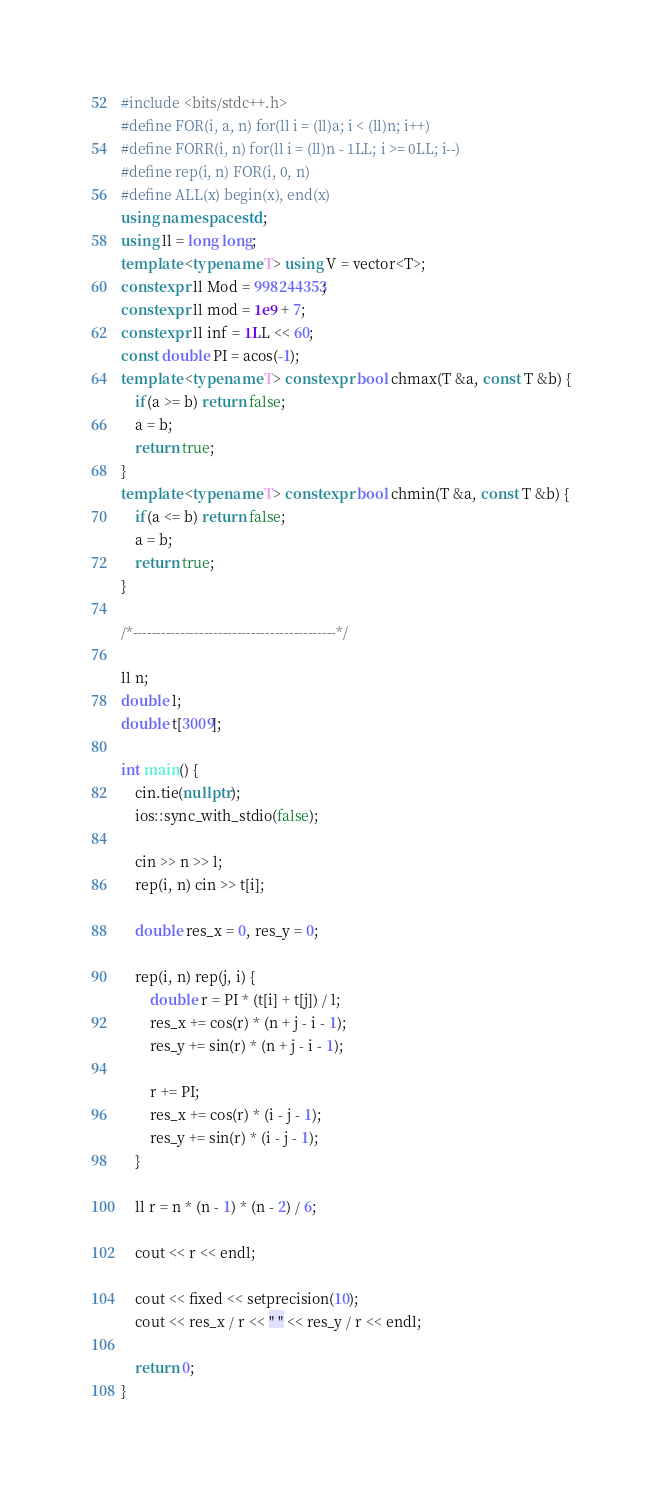Convert code to text. <code><loc_0><loc_0><loc_500><loc_500><_C++_>#include <bits/stdc++.h>
#define FOR(i, a, n) for(ll i = (ll)a; i < (ll)n; i++)
#define FORR(i, n) for(ll i = (ll)n - 1LL; i >= 0LL; i--)
#define rep(i, n) FOR(i, 0, n)
#define ALL(x) begin(x), end(x)
using namespace std;
using ll = long long;
template <typename T> using V = vector<T>;
constexpr ll Mod = 998244353;
constexpr ll mod = 1e9 + 7;
constexpr ll inf = 1LL << 60;
const double PI = acos(-1);
template <typename T> constexpr bool chmax(T &a, const T &b) {
    if(a >= b) return false;
    a = b;
    return true;
}
template <typename T> constexpr bool chmin(T &a, const T &b) {
    if(a <= b) return false;
    a = b;
    return true;
}

/*-------------------------------------------*/

ll n;
double l;
double t[3009];

int main() {
    cin.tie(nullptr);
    ios::sync_with_stdio(false);

    cin >> n >> l;
    rep(i, n) cin >> t[i];

    double res_x = 0, res_y = 0;

    rep(i, n) rep(j, i) {
        double r = PI * (t[i] + t[j]) / l;
        res_x += cos(r) * (n + j - i - 1);
        res_y += sin(r) * (n + j - i - 1);

        r += PI;
        res_x += cos(r) * (i - j - 1);
        res_y += sin(r) * (i - j - 1);
    }

    ll r = n * (n - 1) * (n - 2) / 6;

    cout << r << endl;

    cout << fixed << setprecision(10);
    cout << res_x / r << " " << res_y / r << endl;

    return 0;
}</code> 